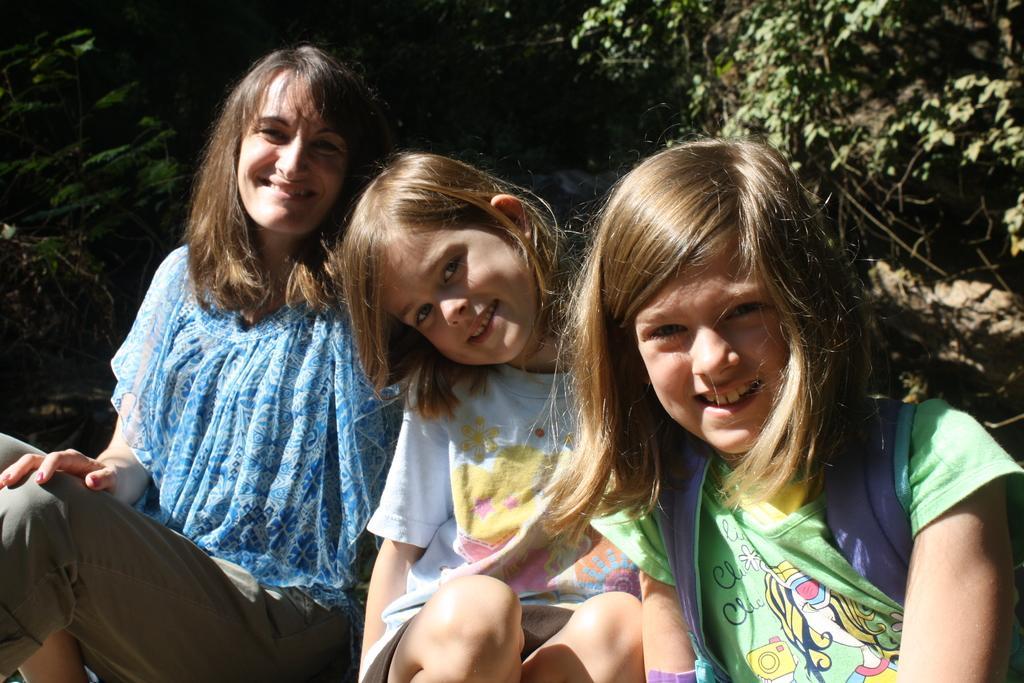In one or two sentences, can you explain what this image depicts? In this image I can see three persons. In front the person is wearing white color dress. In the background I can see few trees in green color. 